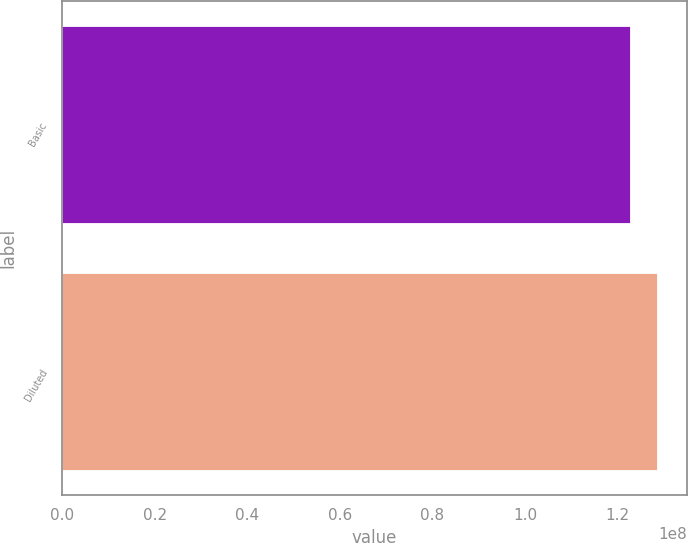Convert chart to OTSL. <chart><loc_0><loc_0><loc_500><loc_500><bar_chart><fcel>Basic<fcel>Diluted<nl><fcel>1.22651e+08<fcel>1.28553e+08<nl></chart> 